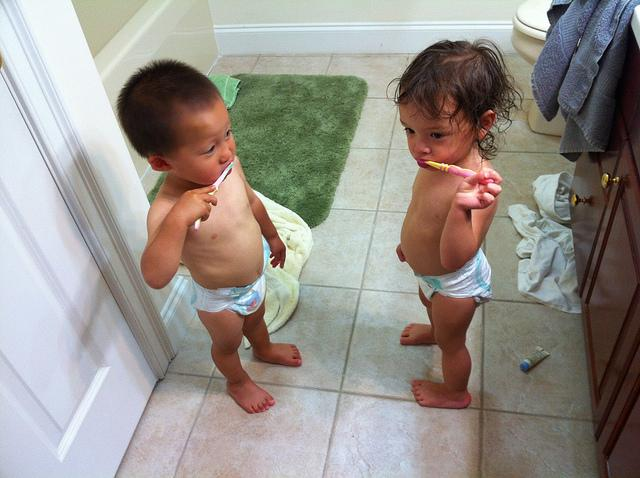How is the kid on the right brushing his teeth differently from the kid on the left?

Choices:
A) electric
B) different toothpaste
C) crying
D) lefthanded lefthanded 